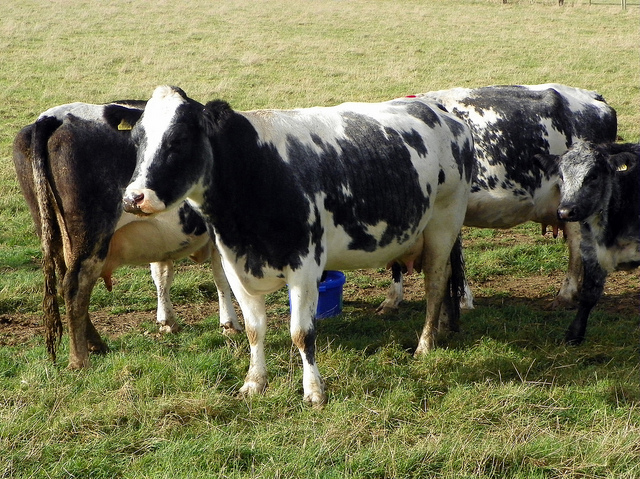How many cows are there? 4 